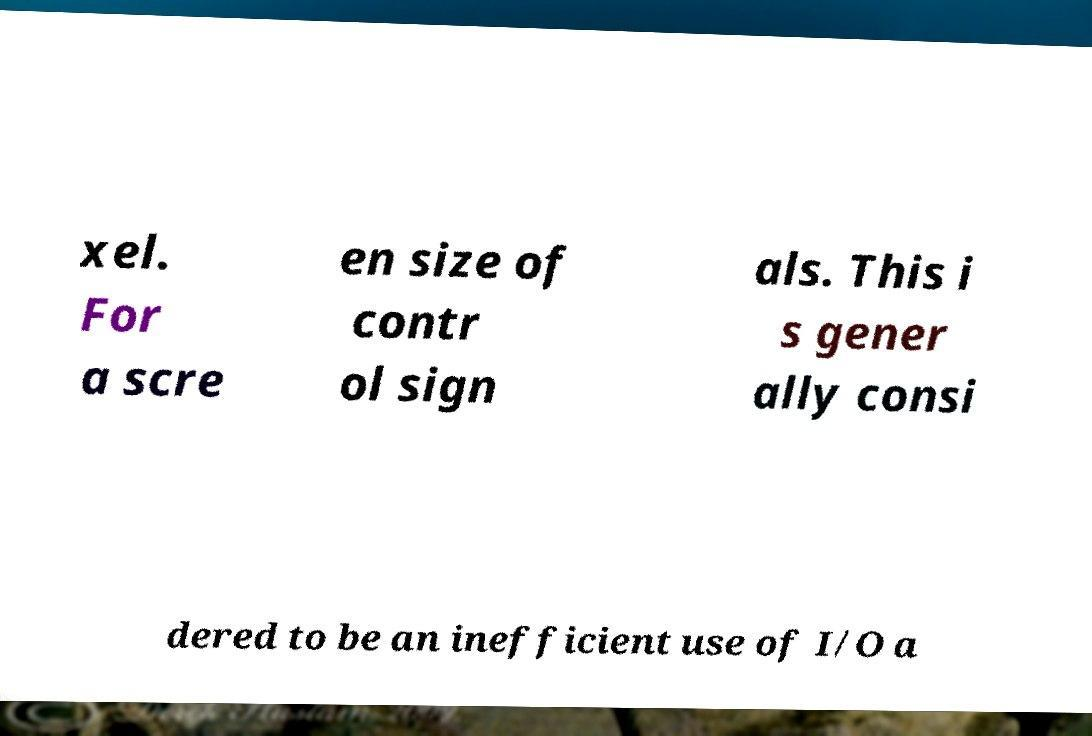Could you extract and type out the text from this image? xel. For a scre en size of contr ol sign als. This i s gener ally consi dered to be an inefficient use of I/O a 